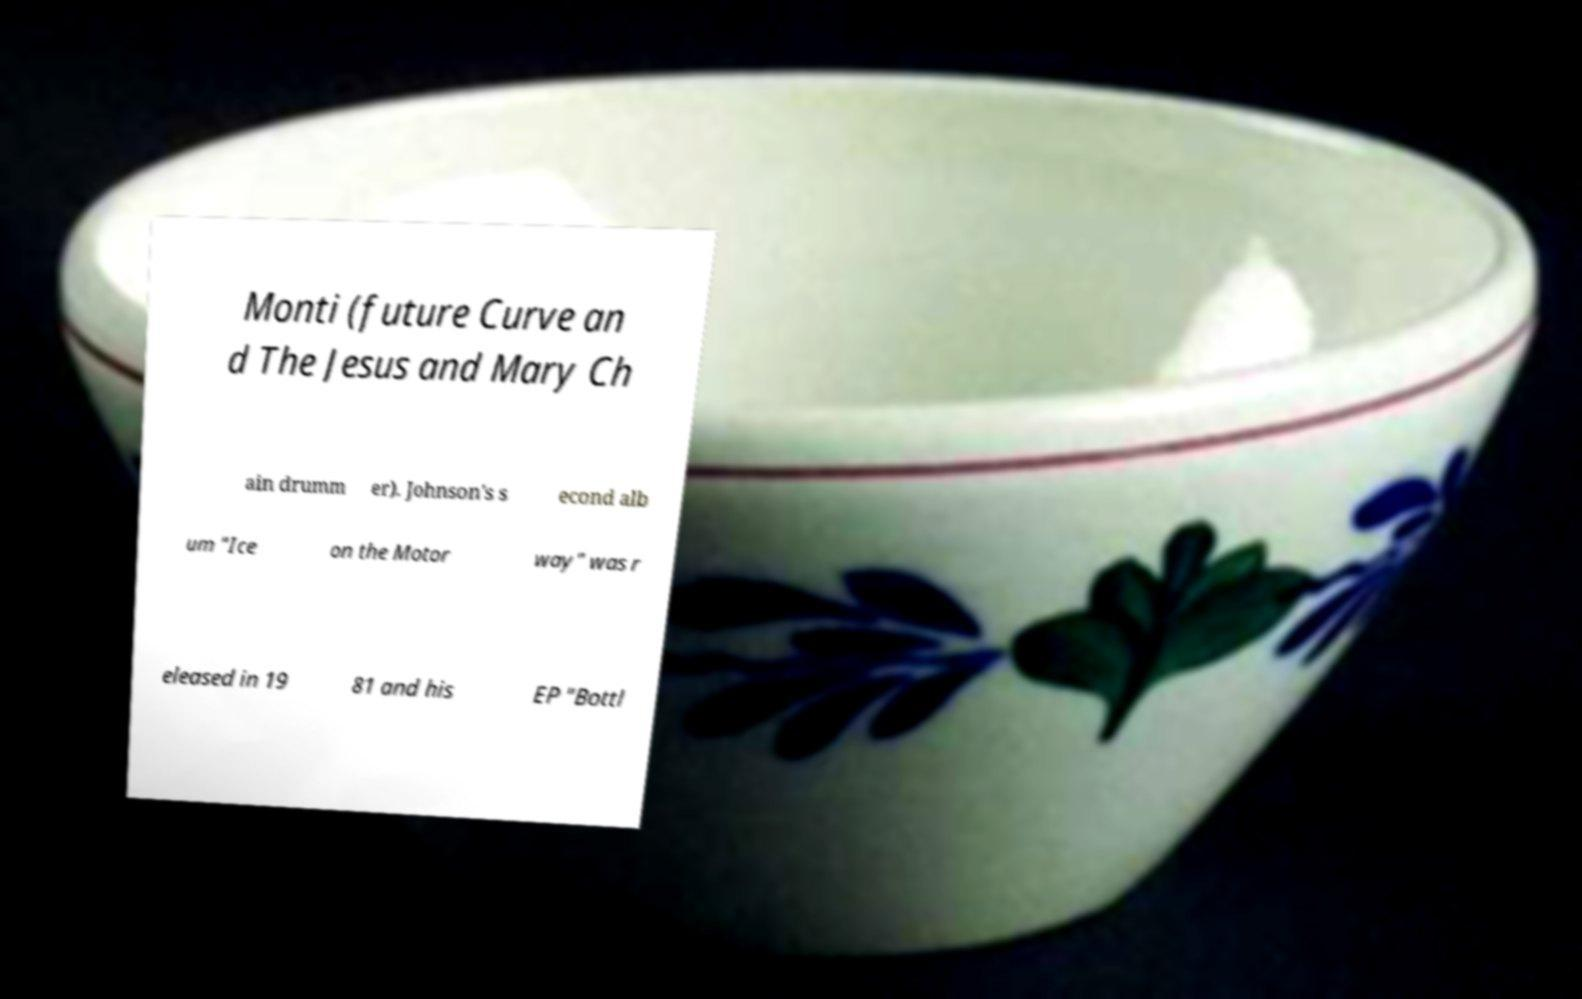What messages or text are displayed in this image? I need them in a readable, typed format. Monti (future Curve an d The Jesus and Mary Ch ain drumm er). Johnson's s econd alb um "Ice on the Motor way" was r eleased in 19 81 and his EP "Bottl 